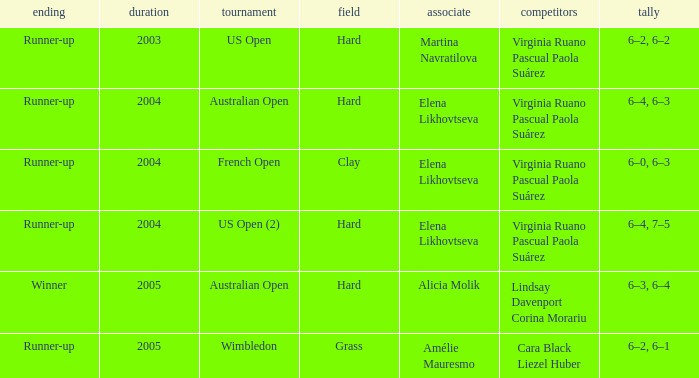When us open (2) is the championship what is the surface? Hard. 